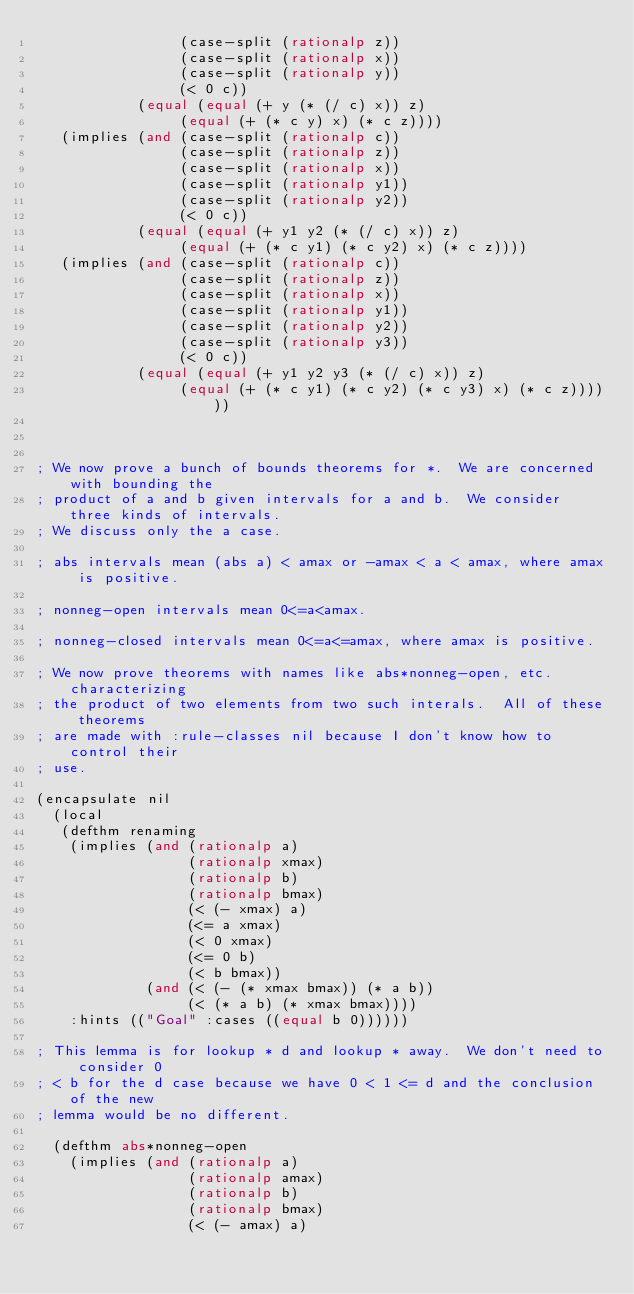<code> <loc_0><loc_0><loc_500><loc_500><_Lisp_>                 (case-split (rationalp z))
                 (case-split (rationalp x))
                 (case-split (rationalp y))
                 (< 0 c))
            (equal (equal (+ y (* (/ c) x)) z)
                 (equal (+ (* c y) x) (* c z))))
   (implies (and (case-split (rationalp c))
                 (case-split (rationalp z))
                 (case-split (rationalp x))
                 (case-split (rationalp y1))
                 (case-split (rationalp y2))
                 (< 0 c))
            (equal (equal (+ y1 y2 (* (/ c) x)) z)
                 (equal (+ (* c y1) (* c y2) x) (* c z))))
   (implies (and (case-split (rationalp c))
                 (case-split (rationalp z))
                 (case-split (rationalp x))
                 (case-split (rationalp y1))
                 (case-split (rationalp y2))
                 (case-split (rationalp y3))
                 (< 0 c))
            (equal (equal (+ y1 y2 y3 (* (/ c) x)) z)
                 (equal (+ (* c y1) (* c y2) (* c y3) x) (* c z))))))



; We now prove a bunch of bounds theorems for *.  We are concerned with bounding the
; product of a and b given intervals for a and b.  We consider three kinds of intervals.
; We discuss only the a case.

; abs intervals mean (abs a) < amax or -amax < a < amax, where amax is positive.

; nonneg-open intervals mean 0<=a<amax.

; nonneg-closed intervals mean 0<=a<=amax, where amax is positive.

; We now prove theorems with names like abs*nonneg-open, etc. characterizing
; the product of two elements from two such interals.  All of these theorems
; are made with :rule-classes nil because I don't know how to control their
; use.

(encapsulate nil
  (local 
   (defthm renaming
    (implies (and (rationalp a)
                  (rationalp xmax)
                  (rationalp b)
                  (rationalp bmax)
                  (< (- xmax) a)
                  (<= a xmax)
                  (< 0 xmax)
                  (<= 0 b)
                  (< b bmax))
             (and (< (- (* xmax bmax)) (* a b))
                  (< (* a b) (* xmax bmax))))
    :hints (("Goal" :cases ((equal b 0))))))

; This lemma is for lookup * d and lookup * away.  We don't need to consider 0
; < b for the d case because we have 0 < 1 <= d and the conclusion of the new
; lemma would be no different.

  (defthm abs*nonneg-open
    (implies (and (rationalp a)
                  (rationalp amax)
                  (rationalp b)
                  (rationalp bmax)
                  (< (- amax) a)</code> 